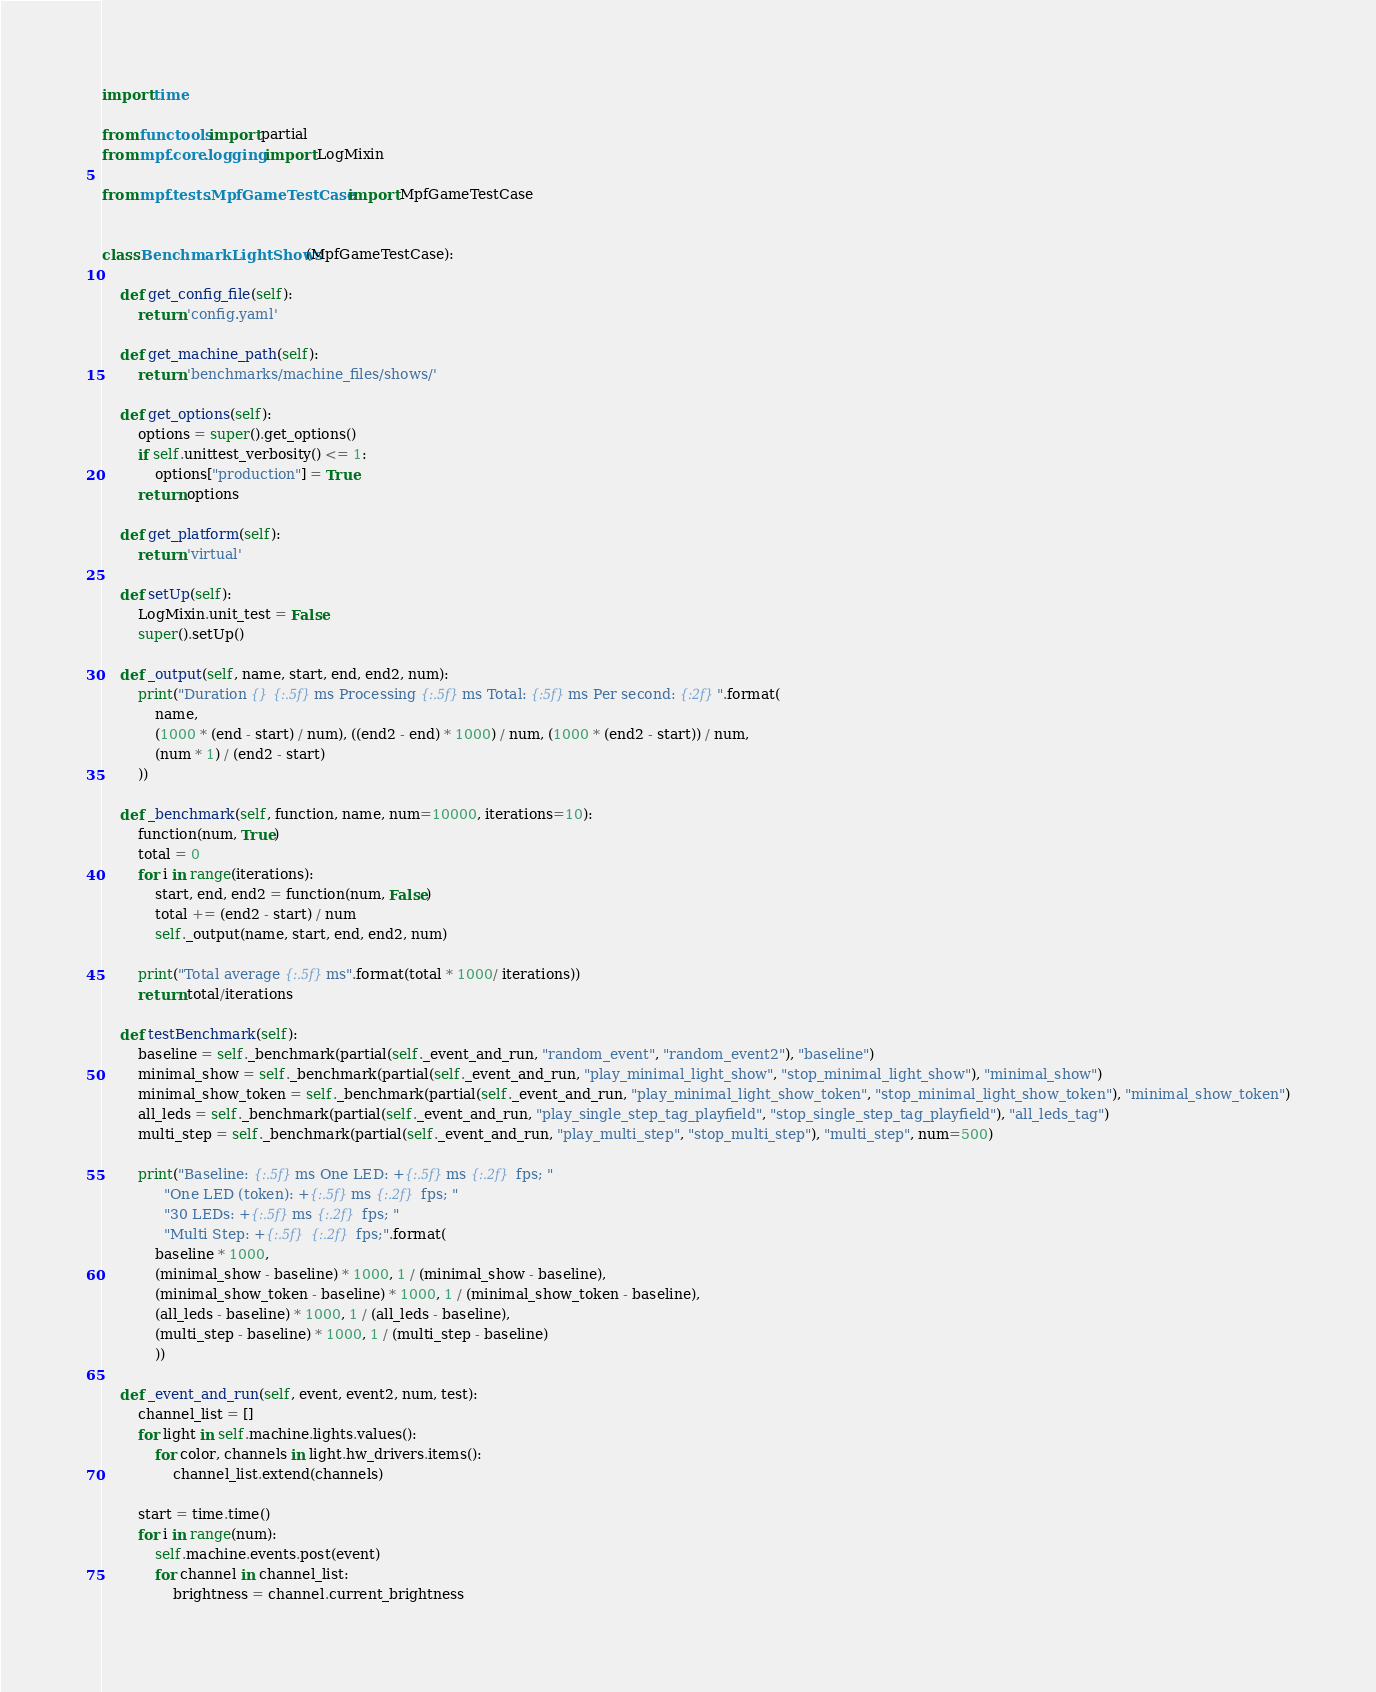<code> <loc_0><loc_0><loc_500><loc_500><_Python_>import time

from functools import partial
from mpf.core.logging import LogMixin

from mpf.tests.MpfGameTestCase import MpfGameTestCase


class BenchmarkLightShows(MpfGameTestCase):

    def get_config_file(self):
        return 'config.yaml'

    def get_machine_path(self):
        return 'benchmarks/machine_files/shows/'

    def get_options(self):
        options = super().get_options()
        if self.unittest_verbosity() <= 1:
            options["production"] = True
        return options

    def get_platform(self):
        return 'virtual'

    def setUp(self):
        LogMixin.unit_test = False
        super().setUp()

    def _output(self, name, start, end, end2, num):
        print("Duration {} {:.5f}ms Processing {:.5f}ms Total: {:5f}ms Per second: {:2f}".format(
            name,
            (1000 * (end - start) / num), ((end2 - end) * 1000) / num, (1000 * (end2 - start)) / num,
            (num * 1) / (end2 - start)
        ))

    def _benchmark(self, function, name, num=10000, iterations=10):
        function(num, True)
        total = 0
        for i in range(iterations):
            start, end, end2 = function(num, False)
            total += (end2 - start) / num
            self._output(name, start, end, end2, num)

        print("Total average {:.5f}ms".format(total * 1000/ iterations))
        return total/iterations

    def testBenchmark(self):
        baseline = self._benchmark(partial(self._event_and_run, "random_event", "random_event2"), "baseline")
        minimal_show = self._benchmark(partial(self._event_and_run, "play_minimal_light_show", "stop_minimal_light_show"), "minimal_show")
        minimal_show_token = self._benchmark(partial(self._event_and_run, "play_minimal_light_show_token", "stop_minimal_light_show_token"), "minimal_show_token")
        all_leds = self._benchmark(partial(self._event_and_run, "play_single_step_tag_playfield", "stop_single_step_tag_playfield"), "all_leds_tag")
        multi_step = self._benchmark(partial(self._event_and_run, "play_multi_step", "stop_multi_step"), "multi_step", num=500)

        print("Baseline: {:.5f}ms One LED: +{:.5f}ms {:.2f} fps; "
              "One LED (token): +{:.5f}ms {:.2f} fps; "
              "30 LEDs: +{:.5f}ms {:.2f} fps; "
              "Multi Step: +{:.5f} {:.2f} fps;".format(
            baseline * 1000,
            (minimal_show - baseline) * 1000, 1 / (minimal_show - baseline),
            (minimal_show_token - baseline) * 1000, 1 / (minimal_show_token - baseline),
            (all_leds - baseline) * 1000, 1 / (all_leds - baseline),
            (multi_step - baseline) * 1000, 1 / (multi_step - baseline)
            ))

    def _event_and_run(self, event, event2, num, test):
        channel_list = []
        for light in self.machine.lights.values():
            for color, channels in light.hw_drivers.items():
                channel_list.extend(channels)

        start = time.time()
        for i in range(num):
            self.machine.events.post(event)
            for channel in channel_list:
                brightness = channel.current_brightness</code> 